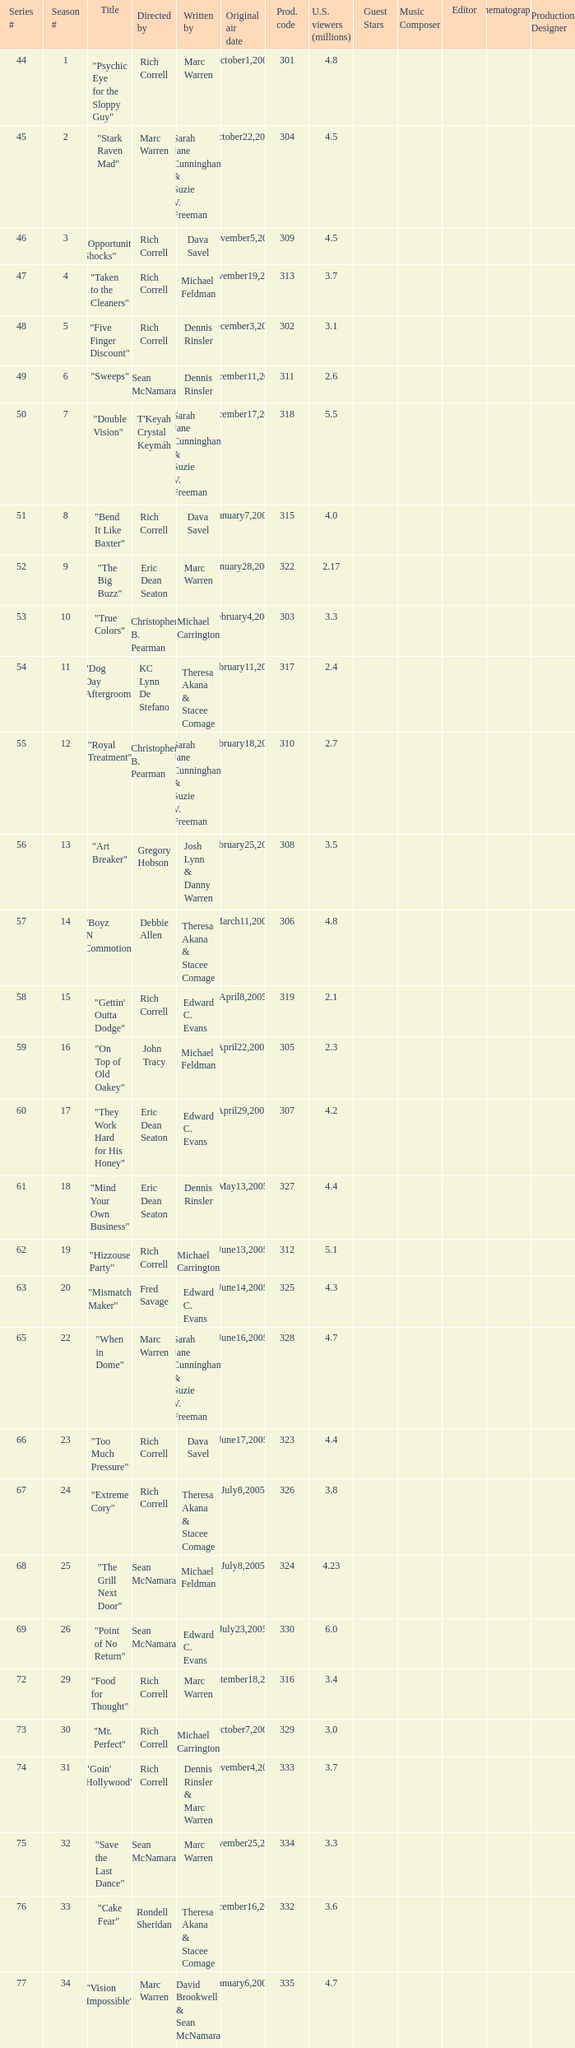What was the production code of the episode directed by Rondell Sheridan?  332.0. 